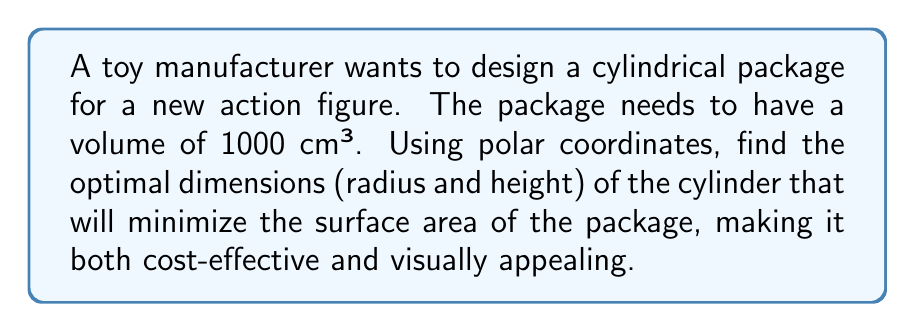What is the answer to this math problem? To solve this problem, we'll follow these steps:

1) Let's define our variables:
   $r$ = radius of the base
   $h$ = height of the cylinder

2) We know the volume is fixed at 1000 cm³:
   $$V = \pi r^2 h = 1000$$

3) The surface area of a cylinder is given by:
   $$S = 2\pi r^2 + 2\pi rh$$

4) We can express $h$ in terms of $r$ using the volume equation:
   $$h = \frac{1000}{\pi r^2}$$

5) Substituting this into the surface area equation:
   $$S = 2\pi r^2 + 2\pi r(\frac{1000}{\pi r^2}) = 2\pi r^2 + \frac{2000}{r}$$

6) To find the minimum surface area, we differentiate $S$ with respect to $r$ and set it to zero:
   $$\frac{dS}{dr} = 4\pi r - \frac{2000}{r^2} = 0$$

7) Solving this equation:
   $$4\pi r^3 = 2000$$
   $$r^3 = \frac{500}{\pi}$$
   $$r = \sqrt[3]{\frac{500}{\pi}} \approx 5.42 \text{ cm}$$

8) We can find $h$ using the volume equation:
   $$h = \frac{1000}{\pi r^2} \approx 10.84 \text{ cm}$$

9) To verify this is a minimum, we can check the second derivative is positive:
   $$\frac{d^2S}{dr^2} = 4\pi + \frac{4000}{r^3} > 0$$

Therefore, the optimal dimensions for the cylindrical package are:
Radius ≈ 5.42 cm
Height ≈ 10.84 cm

These dimensions will minimize the surface area of the package while maintaining the required volume, resulting in a cost-effective and visually balanced design.
Answer: Optimal dimensions: Radius ≈ 5.42 cm, Height ≈ 10.84 cm 